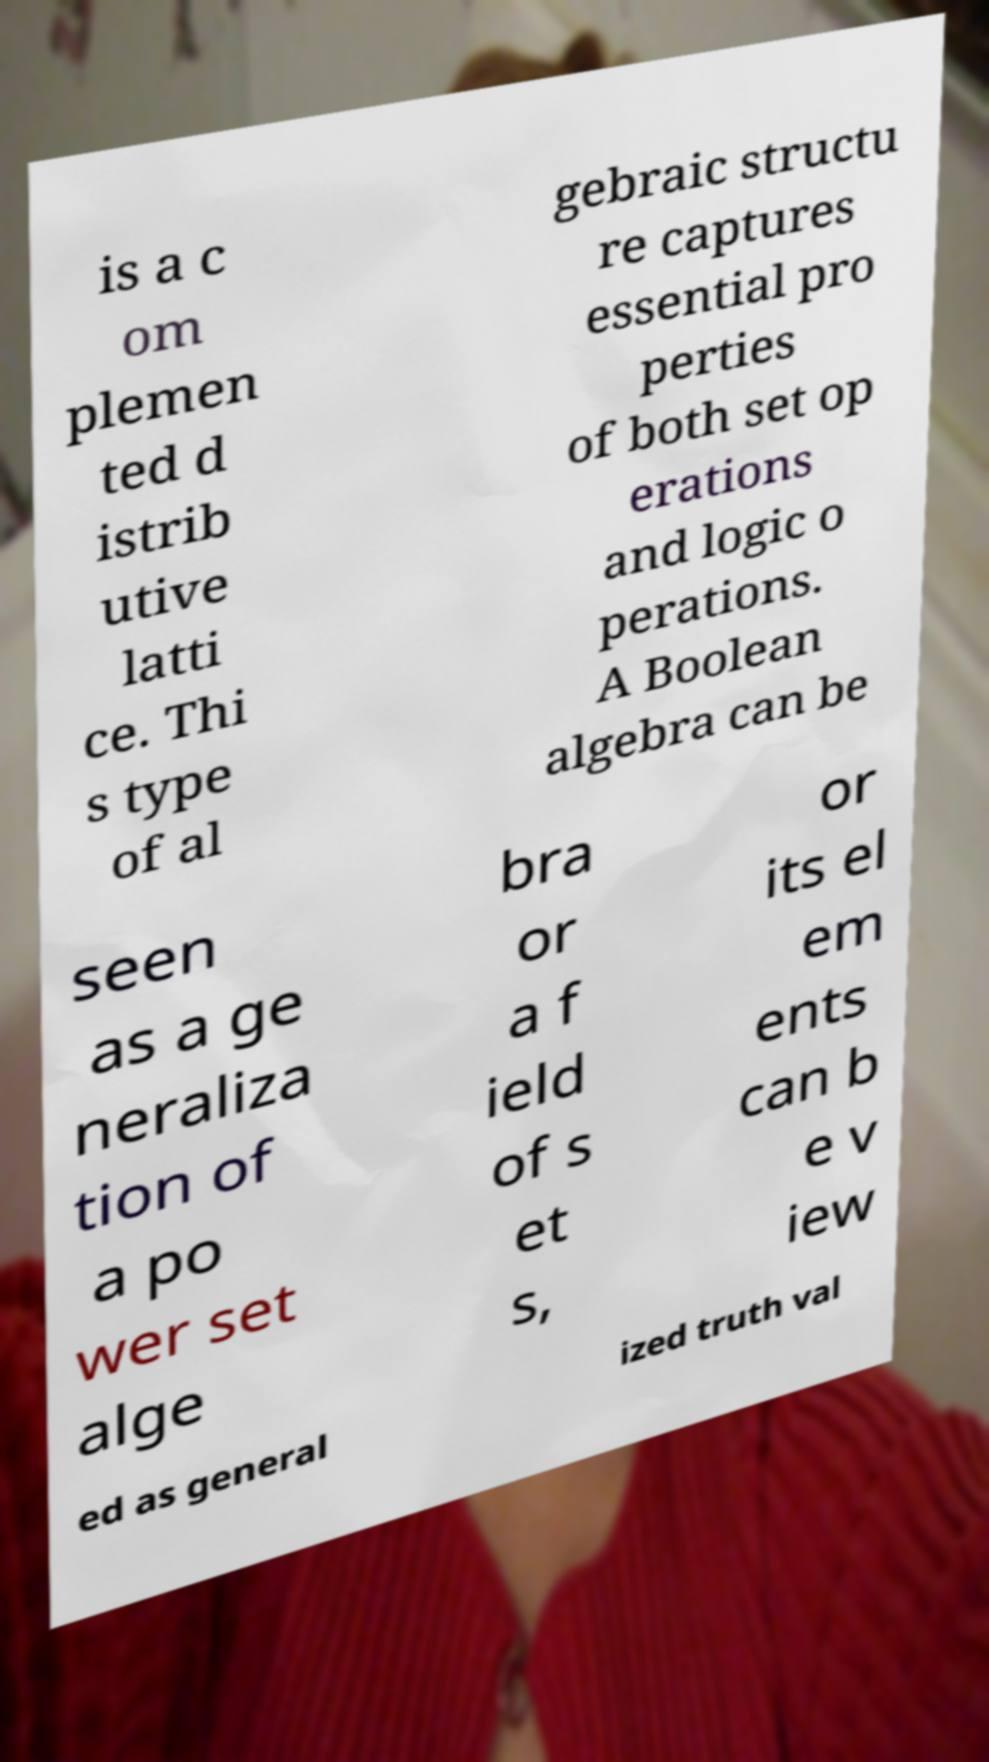Could you assist in decoding the text presented in this image and type it out clearly? is a c om plemen ted d istrib utive latti ce. Thi s type of al gebraic structu re captures essential pro perties of both set op erations and logic o perations. A Boolean algebra can be seen as a ge neraliza tion of a po wer set alge bra or a f ield of s et s, or its el em ents can b e v iew ed as general ized truth val 